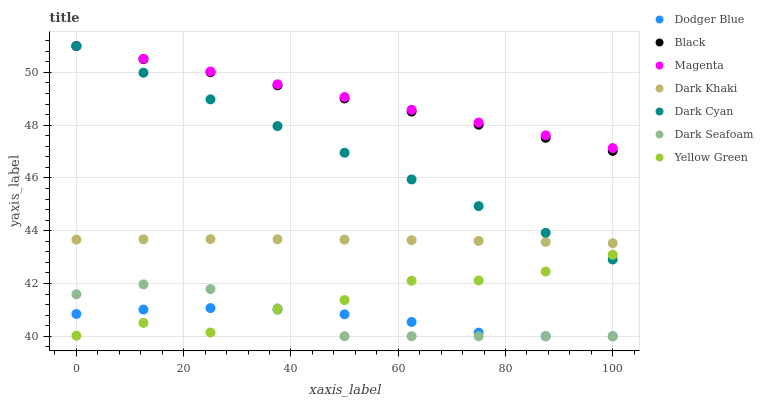Does Dodger Blue have the minimum area under the curve?
Answer yes or no. Yes. Does Magenta have the maximum area under the curve?
Answer yes or no. Yes. Does Dark Khaki have the minimum area under the curve?
Answer yes or no. No. Does Dark Khaki have the maximum area under the curve?
Answer yes or no. No. Is Magenta the smoothest?
Answer yes or no. Yes. Is Yellow Green the roughest?
Answer yes or no. Yes. Is Dark Khaki the smoothest?
Answer yes or no. No. Is Dark Khaki the roughest?
Answer yes or no. No. Does Dark Seafoam have the lowest value?
Answer yes or no. Yes. Does Dark Khaki have the lowest value?
Answer yes or no. No. Does Magenta have the highest value?
Answer yes or no. Yes. Does Dark Khaki have the highest value?
Answer yes or no. No. Is Dodger Blue less than Dark Cyan?
Answer yes or no. Yes. Is Black greater than Dodger Blue?
Answer yes or no. Yes. Does Black intersect Dark Cyan?
Answer yes or no. Yes. Is Black less than Dark Cyan?
Answer yes or no. No. Is Black greater than Dark Cyan?
Answer yes or no. No. Does Dodger Blue intersect Dark Cyan?
Answer yes or no. No. 